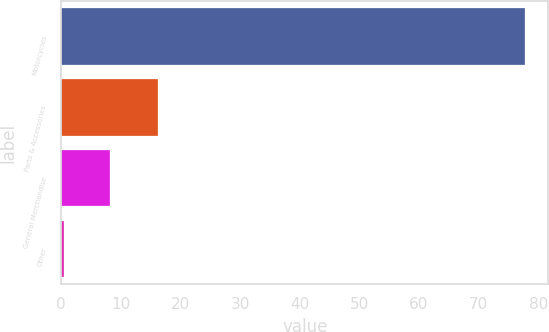Convert chart. <chart><loc_0><loc_0><loc_500><loc_500><bar_chart><fcel>Motorcycles<fcel>Parts & Accessories<fcel>General Merchandise<fcel>Other<nl><fcel>77.8<fcel>16.2<fcel>8.23<fcel>0.5<nl></chart> 